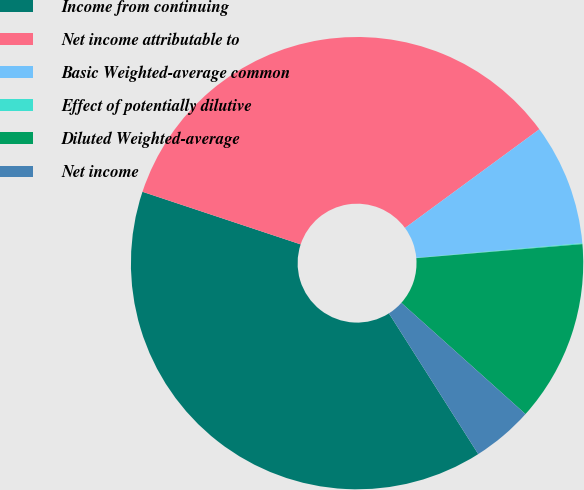Convert chart to OTSL. <chart><loc_0><loc_0><loc_500><loc_500><pie_chart><fcel>Income from continuing<fcel>Net income attributable to<fcel>Basic Weighted-average common<fcel>Effect of potentially dilutive<fcel>Diluted Weighted-average<fcel>Net income<nl><fcel>39.11%<fcel>34.81%<fcel>8.67%<fcel>0.07%<fcel>12.97%<fcel>4.37%<nl></chart> 